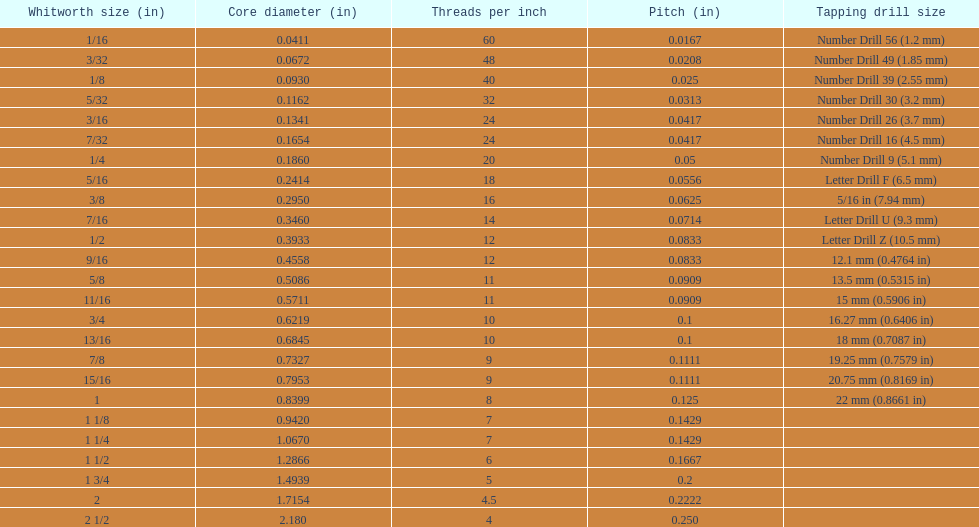Which core diameter (in) succeeds 0.1162. 